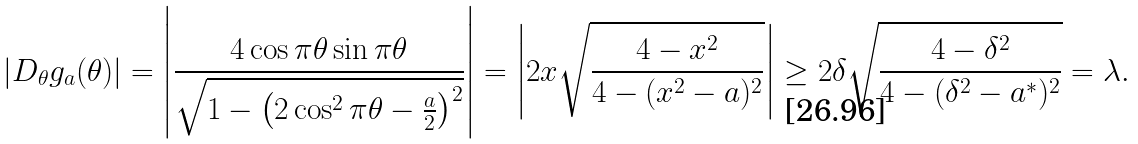Convert formula to latex. <formula><loc_0><loc_0><loc_500><loc_500>\left | D _ { \theta } g _ { a } ( \theta ) \right | = \left | \frac { 4 \cos \pi \theta \sin \pi \theta } { \sqrt { 1 - \left ( 2 \cos ^ { 2 } \pi \theta - \frac { a } { 2 } \right ) ^ { 2 } } } \right | = \left | 2 x \sqrt { \frac { 4 - x ^ { 2 } } { 4 - ( x ^ { 2 } - a ) ^ { 2 } } } \right | \geq 2 \delta \sqrt { \frac { 4 - \delta ^ { 2 } } { 4 - ( \delta ^ { 2 } - a ^ { * } ) ^ { 2 } } } = \lambda .</formula> 